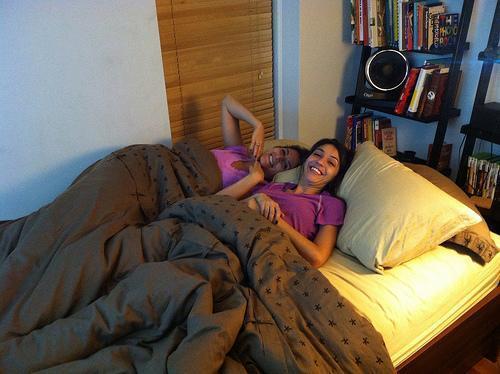How many people are shown?
Give a very brief answer. 2. 